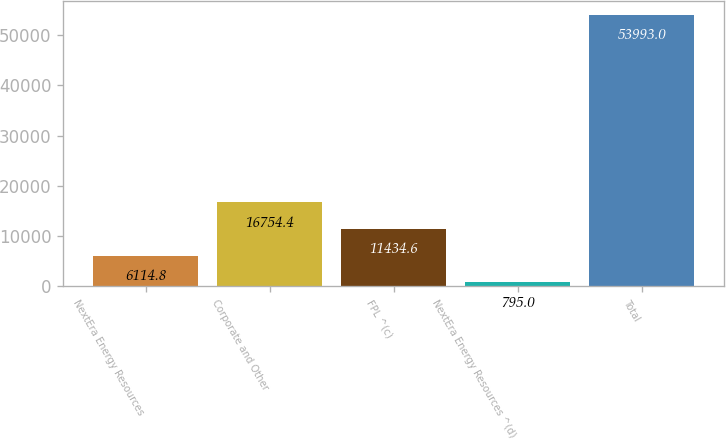<chart> <loc_0><loc_0><loc_500><loc_500><bar_chart><fcel>NextEra Energy Resources<fcel>Corporate and Other<fcel>FPL ^(c)<fcel>NextEra Energy Resources ^(d)<fcel>Total<nl><fcel>6114.8<fcel>16754.4<fcel>11434.6<fcel>795<fcel>53993<nl></chart> 